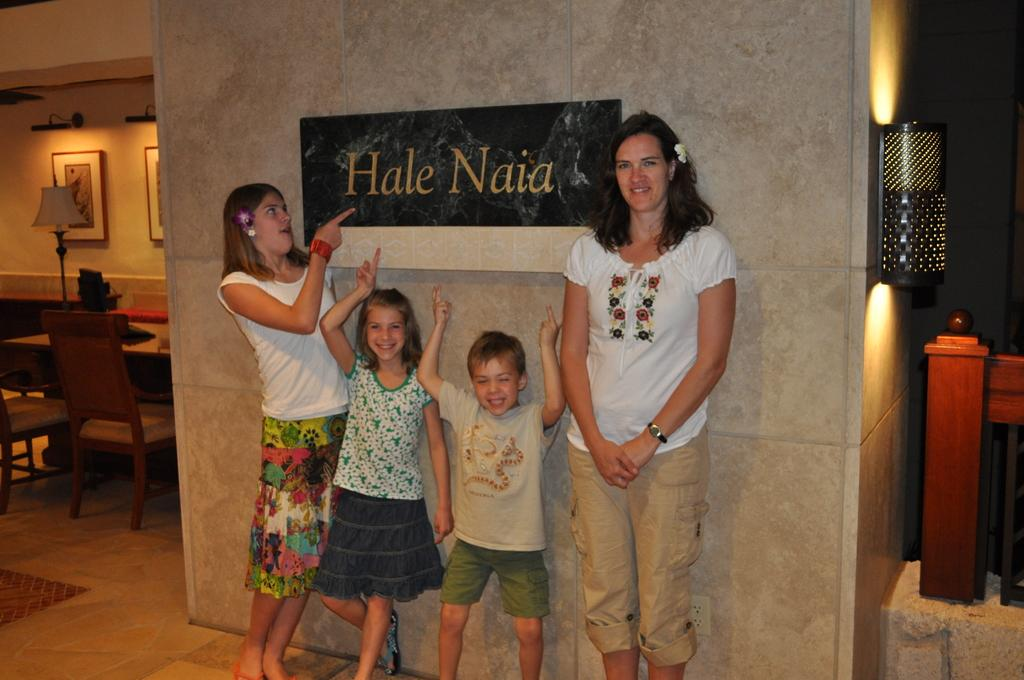How many people are in the image? There are four people in the image: three children and one woman. What are the children and woman doing in the image? The children and woman are standing. What furniture is present in the image? There is a chair, a table, and a lamp in the image. What is attached to the wall in the image? There are frames attached to the wall in the image. Can you see any gloves in the image? There are no gloves present in the image. How many times do the children jump in the image? The children do not jump in the image; they are standing. 